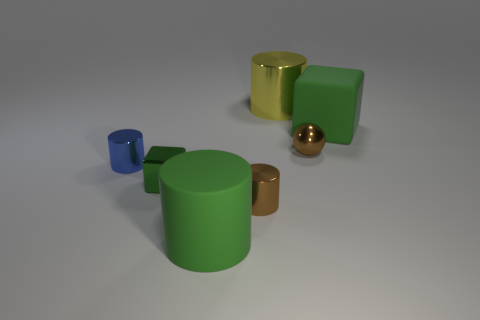How many other objects are the same material as the blue cylinder?
Offer a terse response. 4. Is the number of big green matte objects less than the number of green shiny blocks?
Offer a terse response. No. Are the tiny brown cylinder and the big cylinder that is in front of the brown metal cylinder made of the same material?
Offer a terse response. No. What is the shape of the small brown metal thing that is behind the green metallic thing?
Keep it short and to the point. Sphere. Is there any other thing that has the same color as the large shiny object?
Keep it short and to the point. No. Are there fewer big green cubes to the left of the small shiny block than large yellow cubes?
Your answer should be compact. No. How many rubber blocks are the same size as the brown sphere?
Your answer should be compact. 0. There is a small metallic thing that is the same color as the metal ball; what is its shape?
Your response must be concise. Cylinder. What is the shape of the big matte object that is in front of the large rubber thing that is behind the large green rubber object to the left of the big green block?
Offer a terse response. Cylinder. There is a large cylinder right of the green rubber cylinder; what is its color?
Ensure brevity in your answer.  Yellow. 